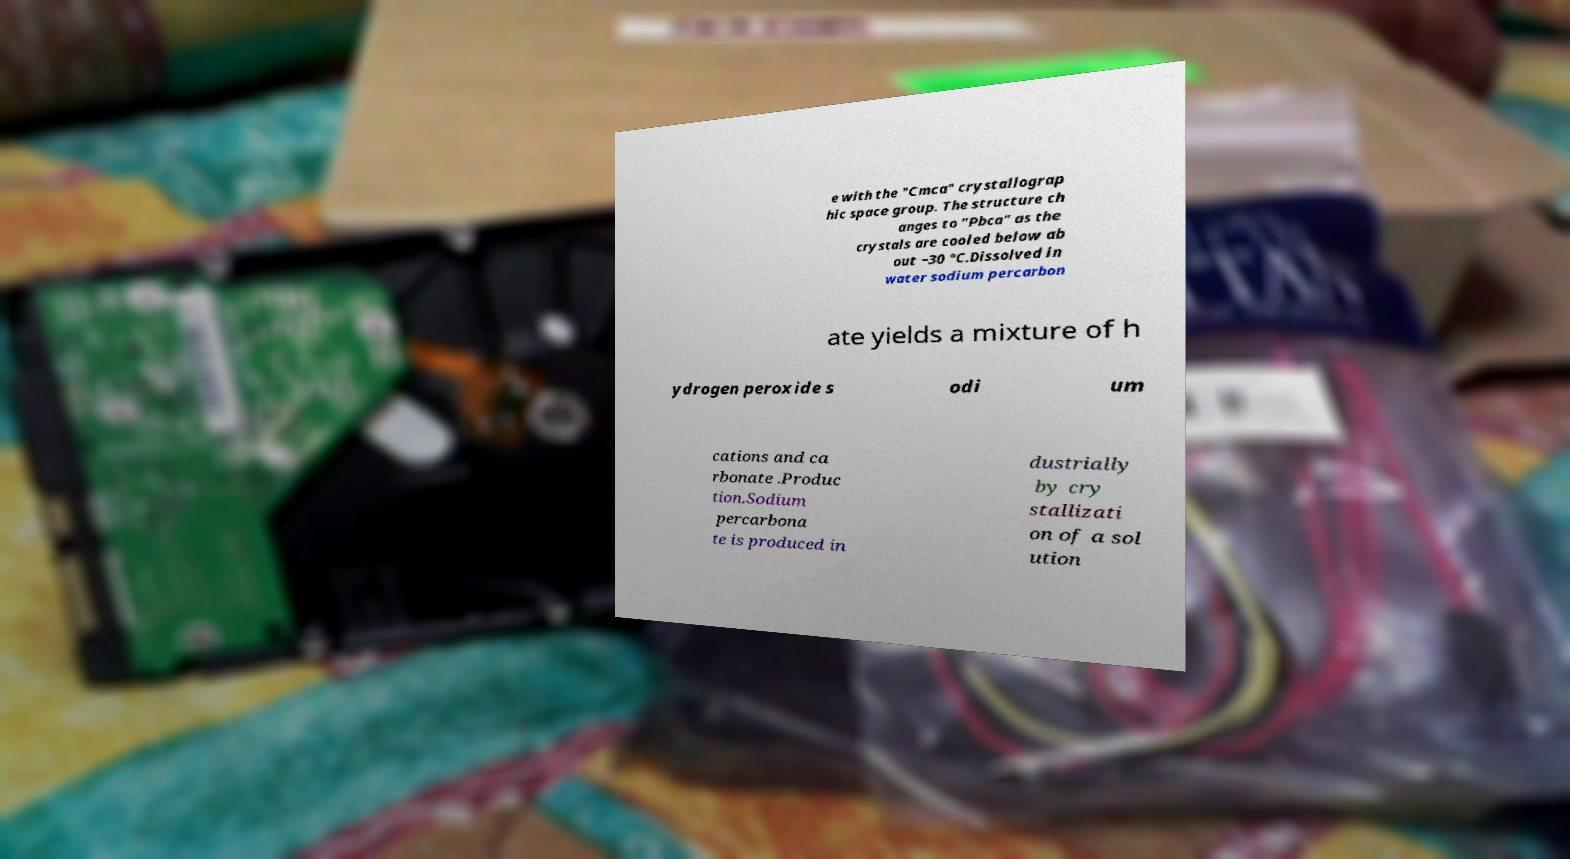For documentation purposes, I need the text within this image transcribed. Could you provide that? e with the "Cmca" crystallograp hic space group. The structure ch anges to "Pbca" as the crystals are cooled below ab out −30 °C.Dissolved in water sodium percarbon ate yields a mixture of h ydrogen peroxide s odi um cations and ca rbonate .Produc tion.Sodium percarbona te is produced in dustrially by cry stallizati on of a sol ution 